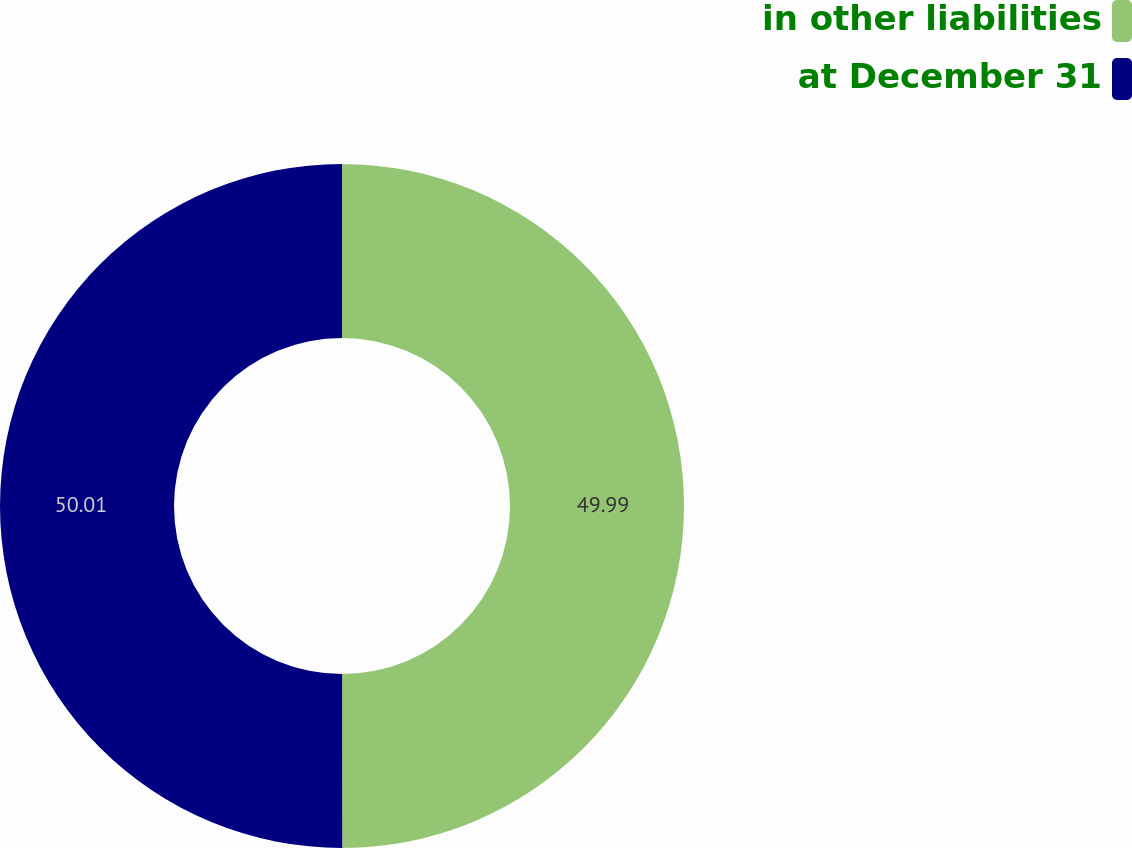<chart> <loc_0><loc_0><loc_500><loc_500><pie_chart><fcel>in other liabilities<fcel>at December 31<nl><fcel>49.99%<fcel>50.01%<nl></chart> 